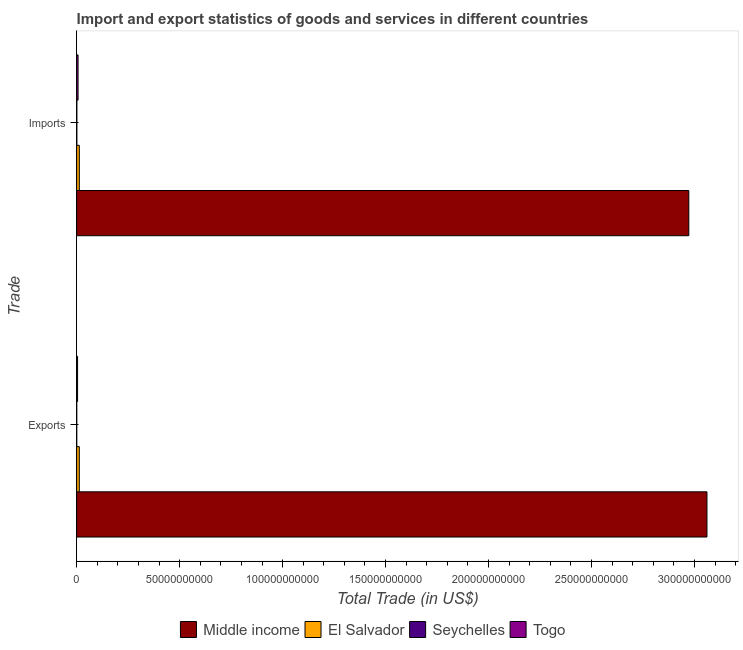Are the number of bars per tick equal to the number of legend labels?
Your answer should be compact. Yes. How many bars are there on the 2nd tick from the top?
Provide a succinct answer. 4. How many bars are there on the 1st tick from the bottom?
Provide a short and direct response. 4. What is the label of the 1st group of bars from the top?
Your answer should be compact. Imports. What is the export of goods and services in Togo?
Your response must be concise. 4.46e+08. Across all countries, what is the maximum export of goods and services?
Your answer should be very brief. 3.06e+11. Across all countries, what is the minimum imports of goods and services?
Provide a short and direct response. 8.44e+07. In which country was the export of goods and services maximum?
Your answer should be compact. Middle income. In which country was the imports of goods and services minimum?
Offer a very short reply. Seychelles. What is the total imports of goods and services in the graph?
Give a very brief answer. 2.99e+11. What is the difference between the export of goods and services in Middle income and that in Seychelles?
Keep it short and to the point. 3.06e+11. What is the difference between the imports of goods and services in Middle income and the export of goods and services in Togo?
Offer a terse response. 2.97e+11. What is the average imports of goods and services per country?
Offer a very short reply. 7.48e+1. What is the difference between the imports of goods and services and export of goods and services in Togo?
Ensure brevity in your answer.  2.34e+08. In how many countries, is the imports of goods and services greater than 140000000000 US$?
Your answer should be very brief. 1. What is the ratio of the imports of goods and services in Middle income to that in El Salvador?
Give a very brief answer. 231.05. In how many countries, is the export of goods and services greater than the average export of goods and services taken over all countries?
Your response must be concise. 1. What does the 2nd bar from the top in Exports represents?
Ensure brevity in your answer.  Seychelles. What does the 3rd bar from the bottom in Exports represents?
Offer a very short reply. Seychelles. How many countries are there in the graph?
Keep it short and to the point. 4. What is the difference between two consecutive major ticks on the X-axis?
Offer a terse response. 5.00e+1. Are the values on the major ticks of X-axis written in scientific E-notation?
Keep it short and to the point. No. Does the graph contain any zero values?
Keep it short and to the point. No. Does the graph contain grids?
Your answer should be compact. No. How many legend labels are there?
Offer a terse response. 4. How are the legend labels stacked?
Give a very brief answer. Horizontal. What is the title of the graph?
Offer a very short reply. Import and export statistics of goods and services in different countries. Does "Uruguay" appear as one of the legend labels in the graph?
Provide a short and direct response. No. What is the label or title of the X-axis?
Ensure brevity in your answer.  Total Trade (in US$). What is the label or title of the Y-axis?
Offer a very short reply. Trade. What is the Total Trade (in US$) in Middle income in Exports?
Offer a very short reply. 3.06e+11. What is the Total Trade (in US$) of El Salvador in Exports?
Keep it short and to the point. 1.28e+09. What is the Total Trade (in US$) in Seychelles in Exports?
Offer a very short reply. 2.19e+07. What is the Total Trade (in US$) of Togo in Exports?
Your answer should be very brief. 4.46e+08. What is the Total Trade (in US$) of Middle income in Imports?
Your answer should be very brief. 2.97e+11. What is the Total Trade (in US$) in El Salvador in Imports?
Keep it short and to the point. 1.29e+09. What is the Total Trade (in US$) of Seychelles in Imports?
Ensure brevity in your answer.  8.44e+07. What is the Total Trade (in US$) of Togo in Imports?
Ensure brevity in your answer.  6.80e+08. Across all Trade, what is the maximum Total Trade (in US$) in Middle income?
Your answer should be compact. 3.06e+11. Across all Trade, what is the maximum Total Trade (in US$) of El Salvador?
Your response must be concise. 1.29e+09. Across all Trade, what is the maximum Total Trade (in US$) of Seychelles?
Ensure brevity in your answer.  8.44e+07. Across all Trade, what is the maximum Total Trade (in US$) in Togo?
Provide a short and direct response. 6.80e+08. Across all Trade, what is the minimum Total Trade (in US$) of Middle income?
Give a very brief answer. 2.97e+11. Across all Trade, what is the minimum Total Trade (in US$) of El Salvador?
Keep it short and to the point. 1.28e+09. Across all Trade, what is the minimum Total Trade (in US$) in Seychelles?
Give a very brief answer. 2.19e+07. Across all Trade, what is the minimum Total Trade (in US$) of Togo?
Make the answer very short. 4.46e+08. What is the total Total Trade (in US$) of Middle income in the graph?
Offer a very short reply. 6.03e+11. What is the total Total Trade (in US$) of El Salvador in the graph?
Offer a terse response. 2.57e+09. What is the total Total Trade (in US$) of Seychelles in the graph?
Ensure brevity in your answer.  1.06e+08. What is the total Total Trade (in US$) of Togo in the graph?
Make the answer very short. 1.13e+09. What is the difference between the Total Trade (in US$) of Middle income in Exports and that in Imports?
Make the answer very short. 8.82e+09. What is the difference between the Total Trade (in US$) in El Salvador in Exports and that in Imports?
Make the answer very short. -5.88e+06. What is the difference between the Total Trade (in US$) in Seychelles in Exports and that in Imports?
Keep it short and to the point. -6.26e+07. What is the difference between the Total Trade (in US$) in Togo in Exports and that in Imports?
Make the answer very short. -2.34e+08. What is the difference between the Total Trade (in US$) of Middle income in Exports and the Total Trade (in US$) of El Salvador in Imports?
Provide a succinct answer. 3.05e+11. What is the difference between the Total Trade (in US$) in Middle income in Exports and the Total Trade (in US$) in Seychelles in Imports?
Keep it short and to the point. 3.06e+11. What is the difference between the Total Trade (in US$) in Middle income in Exports and the Total Trade (in US$) in Togo in Imports?
Your answer should be compact. 3.05e+11. What is the difference between the Total Trade (in US$) in El Salvador in Exports and the Total Trade (in US$) in Seychelles in Imports?
Offer a very short reply. 1.20e+09. What is the difference between the Total Trade (in US$) of El Salvador in Exports and the Total Trade (in US$) of Togo in Imports?
Provide a short and direct response. 6.01e+08. What is the difference between the Total Trade (in US$) of Seychelles in Exports and the Total Trade (in US$) of Togo in Imports?
Make the answer very short. -6.58e+08. What is the average Total Trade (in US$) in Middle income per Trade?
Offer a very short reply. 3.02e+11. What is the average Total Trade (in US$) of El Salvador per Trade?
Ensure brevity in your answer.  1.28e+09. What is the average Total Trade (in US$) of Seychelles per Trade?
Make the answer very short. 5.32e+07. What is the average Total Trade (in US$) in Togo per Trade?
Your response must be concise. 5.63e+08. What is the difference between the Total Trade (in US$) of Middle income and Total Trade (in US$) of El Salvador in Exports?
Your response must be concise. 3.05e+11. What is the difference between the Total Trade (in US$) of Middle income and Total Trade (in US$) of Seychelles in Exports?
Provide a succinct answer. 3.06e+11. What is the difference between the Total Trade (in US$) of Middle income and Total Trade (in US$) of Togo in Exports?
Offer a very short reply. 3.06e+11. What is the difference between the Total Trade (in US$) in El Salvador and Total Trade (in US$) in Seychelles in Exports?
Keep it short and to the point. 1.26e+09. What is the difference between the Total Trade (in US$) in El Salvador and Total Trade (in US$) in Togo in Exports?
Provide a short and direct response. 8.35e+08. What is the difference between the Total Trade (in US$) of Seychelles and Total Trade (in US$) of Togo in Exports?
Make the answer very short. -4.24e+08. What is the difference between the Total Trade (in US$) in Middle income and Total Trade (in US$) in El Salvador in Imports?
Your answer should be very brief. 2.96e+11. What is the difference between the Total Trade (in US$) of Middle income and Total Trade (in US$) of Seychelles in Imports?
Your answer should be compact. 2.97e+11. What is the difference between the Total Trade (in US$) of Middle income and Total Trade (in US$) of Togo in Imports?
Provide a succinct answer. 2.97e+11. What is the difference between the Total Trade (in US$) in El Salvador and Total Trade (in US$) in Seychelles in Imports?
Your answer should be very brief. 1.20e+09. What is the difference between the Total Trade (in US$) of El Salvador and Total Trade (in US$) of Togo in Imports?
Ensure brevity in your answer.  6.07e+08. What is the difference between the Total Trade (in US$) of Seychelles and Total Trade (in US$) of Togo in Imports?
Provide a succinct answer. -5.95e+08. What is the ratio of the Total Trade (in US$) in Middle income in Exports to that in Imports?
Your response must be concise. 1.03. What is the ratio of the Total Trade (in US$) in El Salvador in Exports to that in Imports?
Give a very brief answer. 1. What is the ratio of the Total Trade (in US$) in Seychelles in Exports to that in Imports?
Your response must be concise. 0.26. What is the ratio of the Total Trade (in US$) in Togo in Exports to that in Imports?
Keep it short and to the point. 0.66. What is the difference between the highest and the second highest Total Trade (in US$) of Middle income?
Give a very brief answer. 8.82e+09. What is the difference between the highest and the second highest Total Trade (in US$) of El Salvador?
Offer a very short reply. 5.88e+06. What is the difference between the highest and the second highest Total Trade (in US$) of Seychelles?
Ensure brevity in your answer.  6.26e+07. What is the difference between the highest and the second highest Total Trade (in US$) of Togo?
Offer a very short reply. 2.34e+08. What is the difference between the highest and the lowest Total Trade (in US$) in Middle income?
Offer a very short reply. 8.82e+09. What is the difference between the highest and the lowest Total Trade (in US$) in El Salvador?
Your response must be concise. 5.88e+06. What is the difference between the highest and the lowest Total Trade (in US$) in Seychelles?
Your answer should be very brief. 6.26e+07. What is the difference between the highest and the lowest Total Trade (in US$) of Togo?
Your answer should be compact. 2.34e+08. 